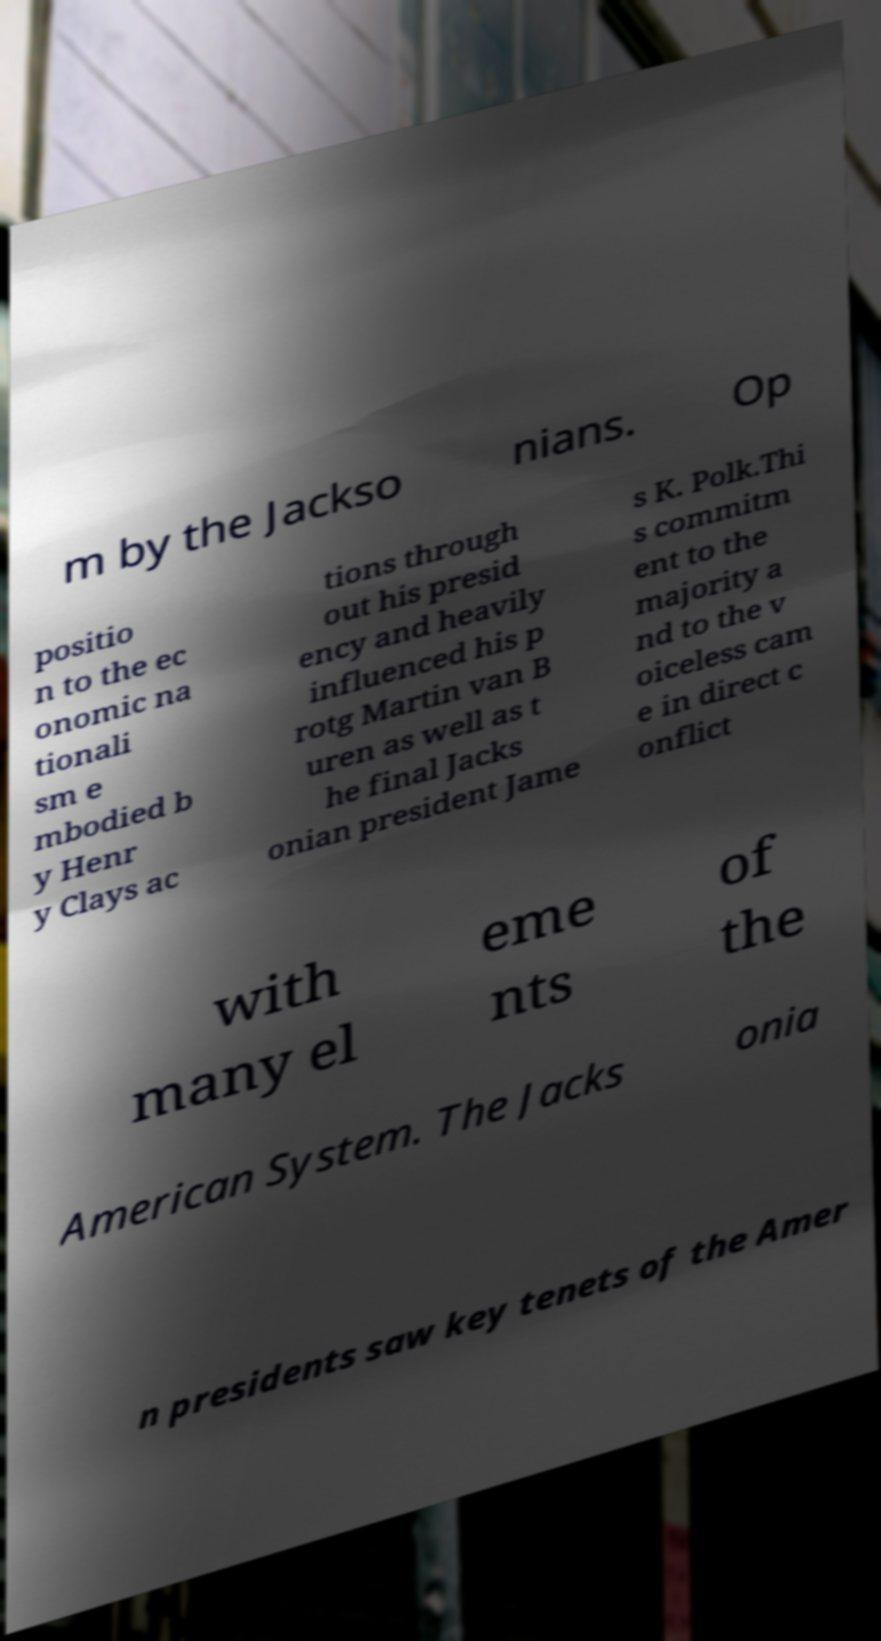I need the written content from this picture converted into text. Can you do that? m by the Jackso nians. Op positio n to the ec onomic na tionali sm e mbodied b y Henr y Clays ac tions through out his presid ency and heavily influenced his p rotg Martin van B uren as well as t he final Jacks onian president Jame s K. Polk.Thi s commitm ent to the majority a nd to the v oiceless cam e in direct c onflict with many el eme nts of the American System. The Jacks onia n presidents saw key tenets of the Amer 